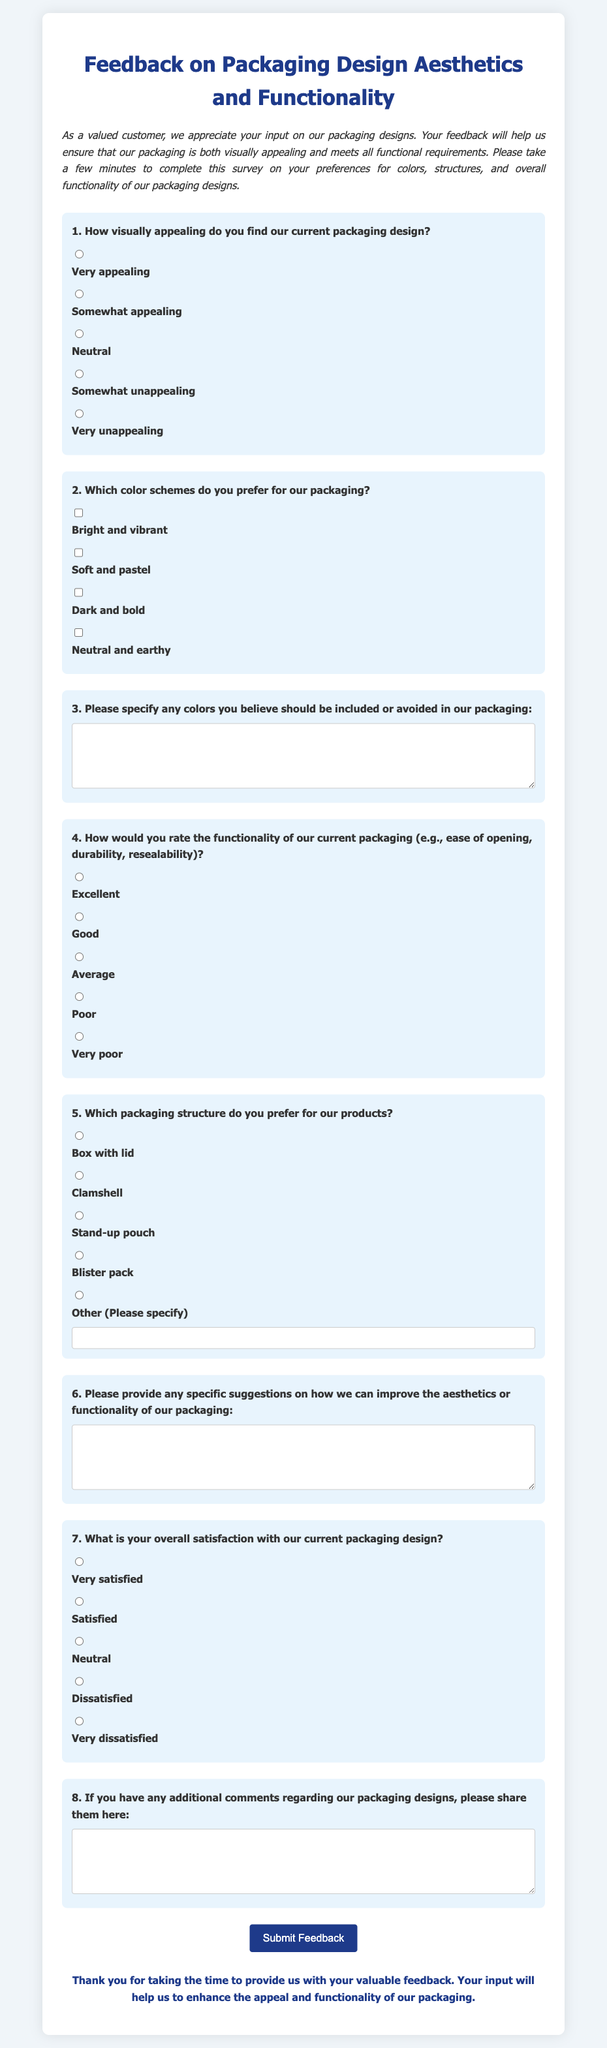What is the title of the survey? The title of the survey is stated at the top of the document.
Answer: Feedback on Packaging Design Aesthetics and Functionality How many main questions are included in the survey? The number of questions can be counted from the form, including additional comment sections.
Answer: Eight Which structure is not listed as a preference in the survey? The question lists various packaging structures, asking for preferences, so the answer would be any option not mentioned.
Answer: None (all options are listed) What is the background color of the survey? The background color is specified in the style section of the document.
Answer: Light gray (#f0f5f9) What type of input does the question about color schemes allow? This question allows customers to select their preferred color schemes from multiple options.
Answer: Checkbox What type of feedback is solicited in question 6? The feedback requested in question 6 is specific suggestions for improvement.
Answer: Suggestions How does the survey thank participants after completion? A thank you message is displayed at the end of the survey to express gratitude for feedback.
Answer: Thank you for taking the time to provide us with your valuable feedback What is the maximum width of the survey form? The maximum width is defined in the CSS styles for the survey container.
Answer: 800 pixels 